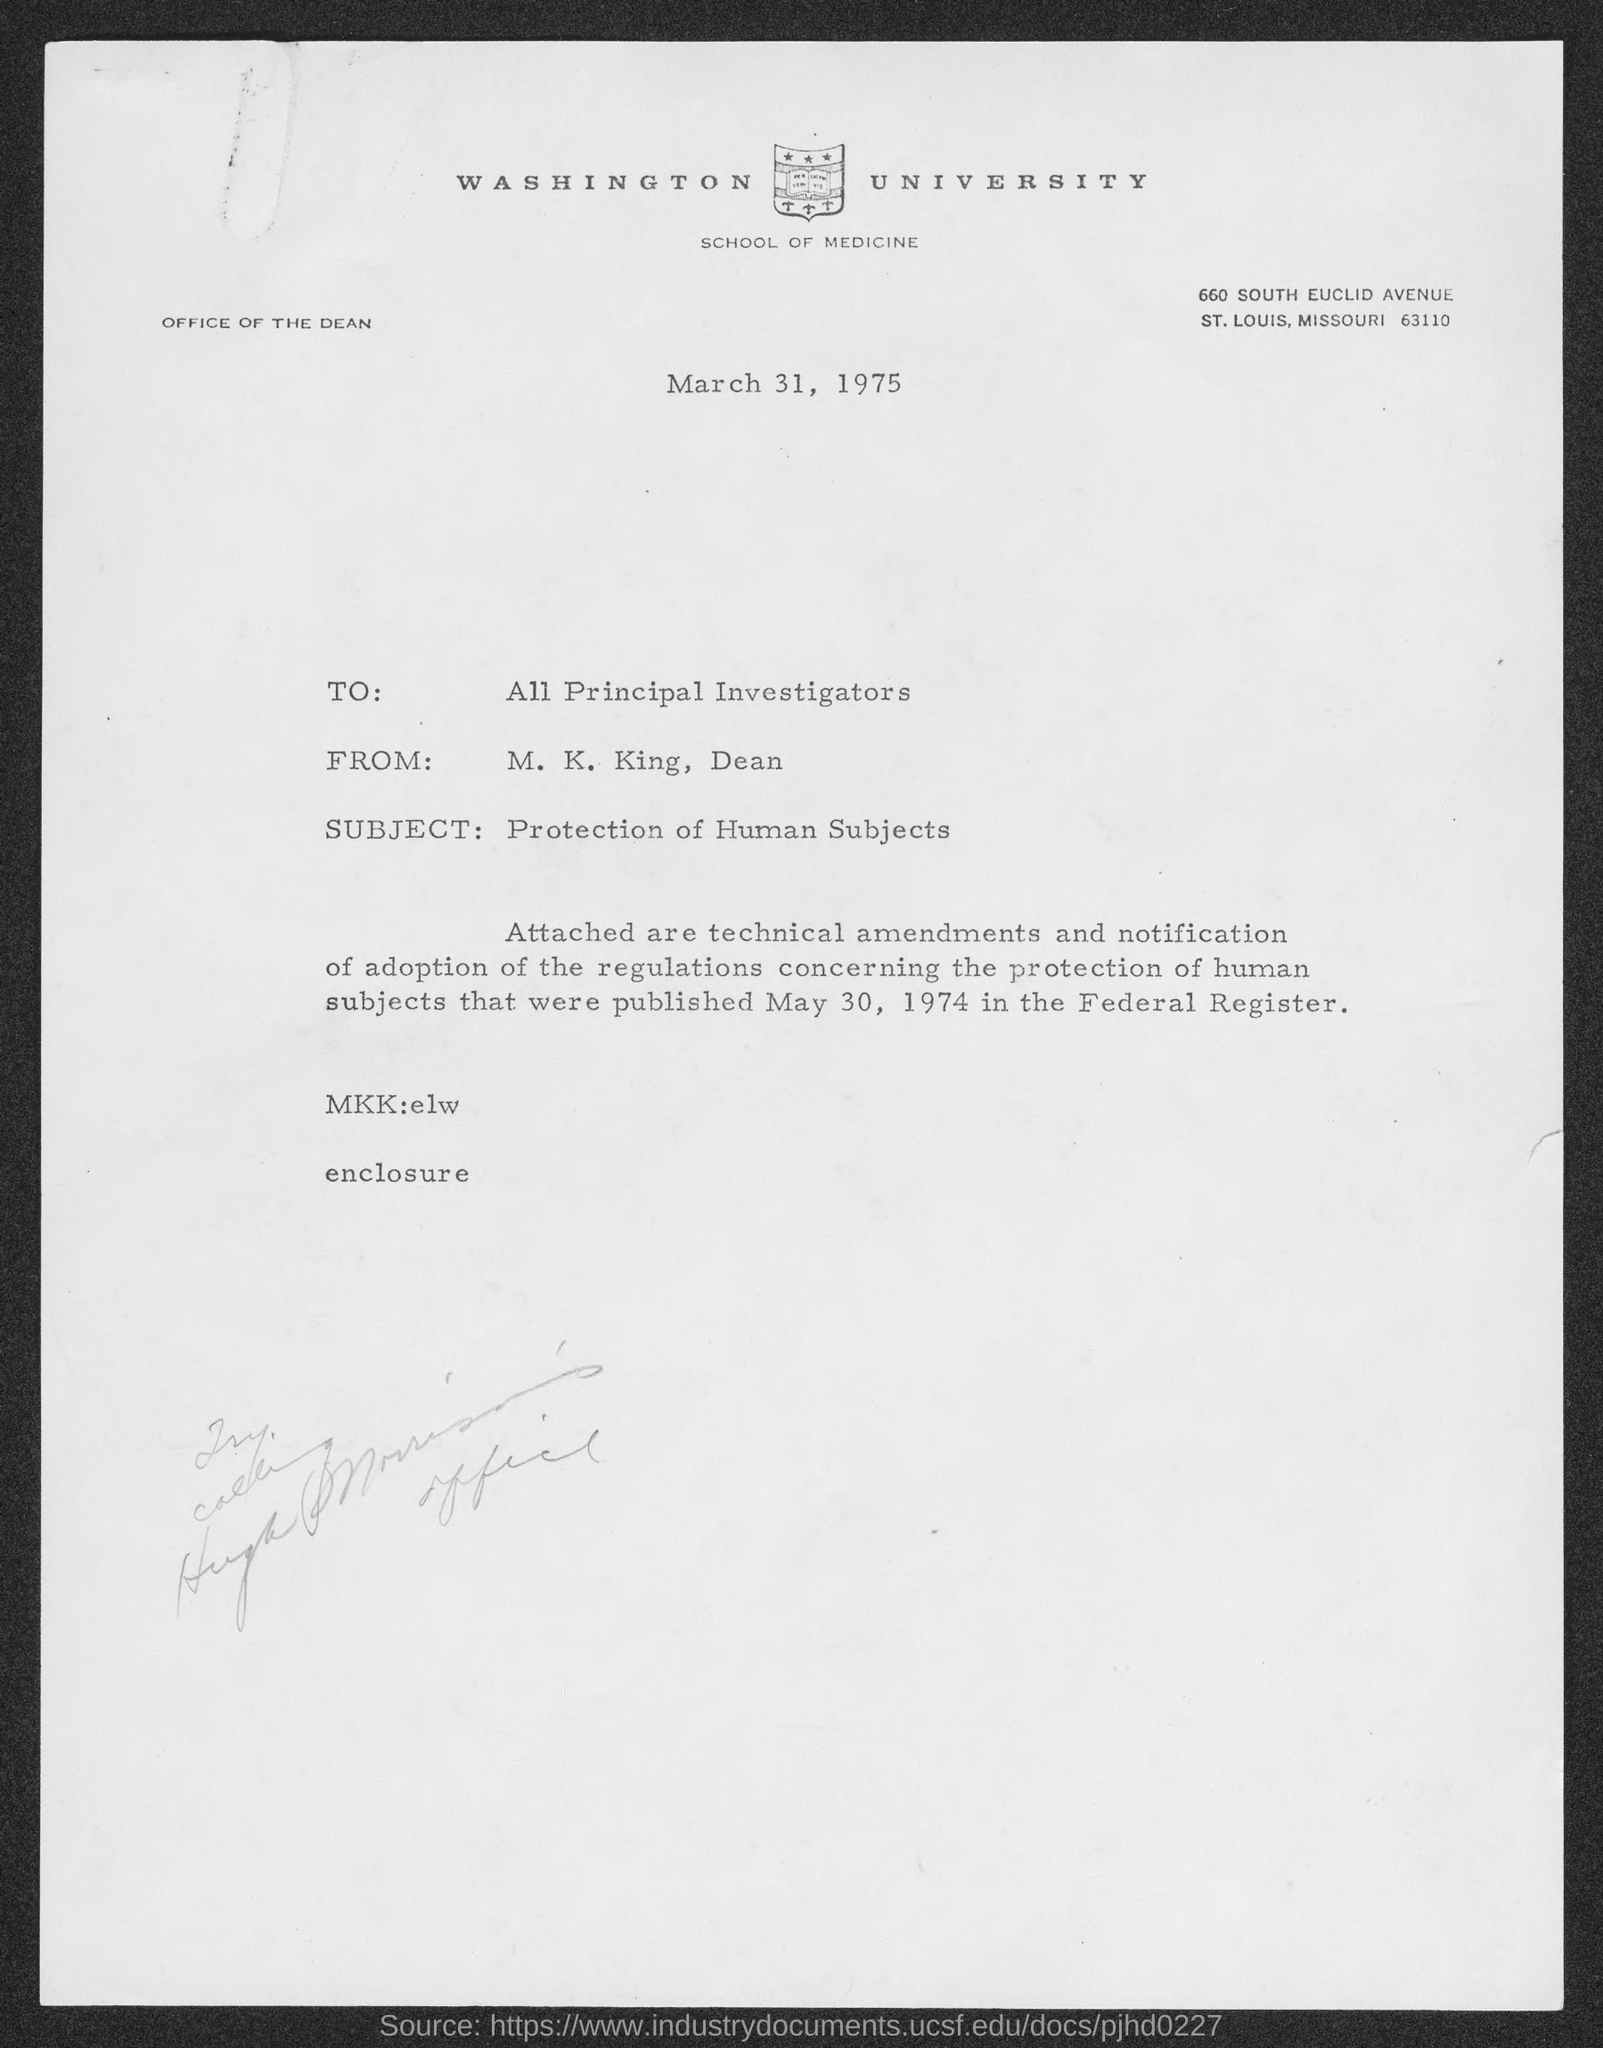Mention a couple of crucial points in this snapshot. The subject of this letter is the protection of human subjects. The letter head mentions Washington University. The sender of this letter is M. K. King, who is also the Dean. The letter is intended for all Principal Investigators. The date mentioned in the letter is March 31, 1975. 